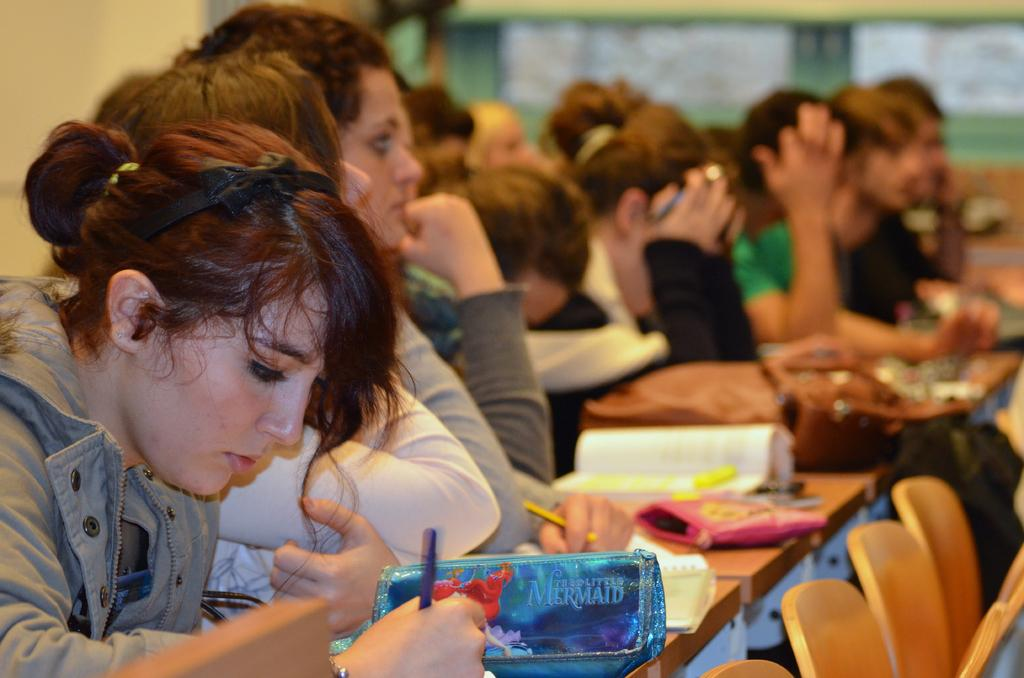What type of furniture is located on the right side of the image? There are chairs on the right side of the image. What can be seen on the table in the image? There are objects on a table in the image. Who or what is visible in the image? There are people visible in the image. What is in the background of the image? There is a wall in the background of the image. Can you see a rifle in the image? No, there is no rifle present in the image. What does the tongue of the person in the image taste? There is no information about the taste of anyone's tongue in the image. 